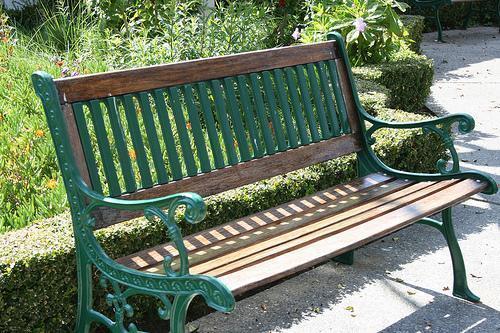How many benches are seen?
Give a very brief answer. 1. 